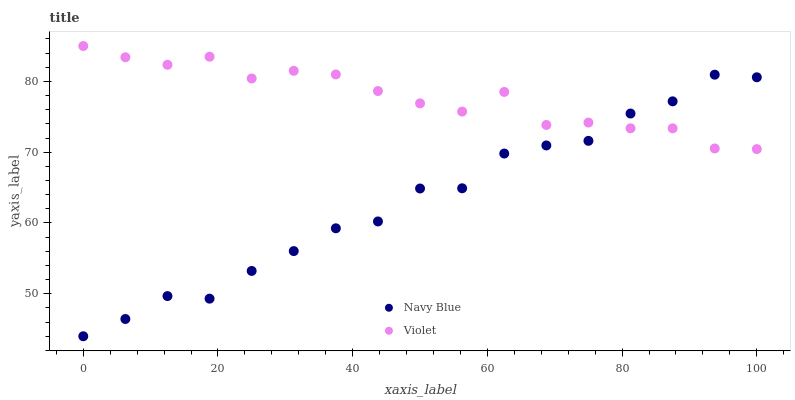Does Navy Blue have the minimum area under the curve?
Answer yes or no. Yes. Does Violet have the maximum area under the curve?
Answer yes or no. Yes. Does Violet have the minimum area under the curve?
Answer yes or no. No. Is Violet the smoothest?
Answer yes or no. Yes. Is Navy Blue the roughest?
Answer yes or no. Yes. Is Violet the roughest?
Answer yes or no. No. Does Navy Blue have the lowest value?
Answer yes or no. Yes. Does Violet have the lowest value?
Answer yes or no. No. Does Violet have the highest value?
Answer yes or no. Yes. Does Violet intersect Navy Blue?
Answer yes or no. Yes. Is Violet less than Navy Blue?
Answer yes or no. No. Is Violet greater than Navy Blue?
Answer yes or no. No. 